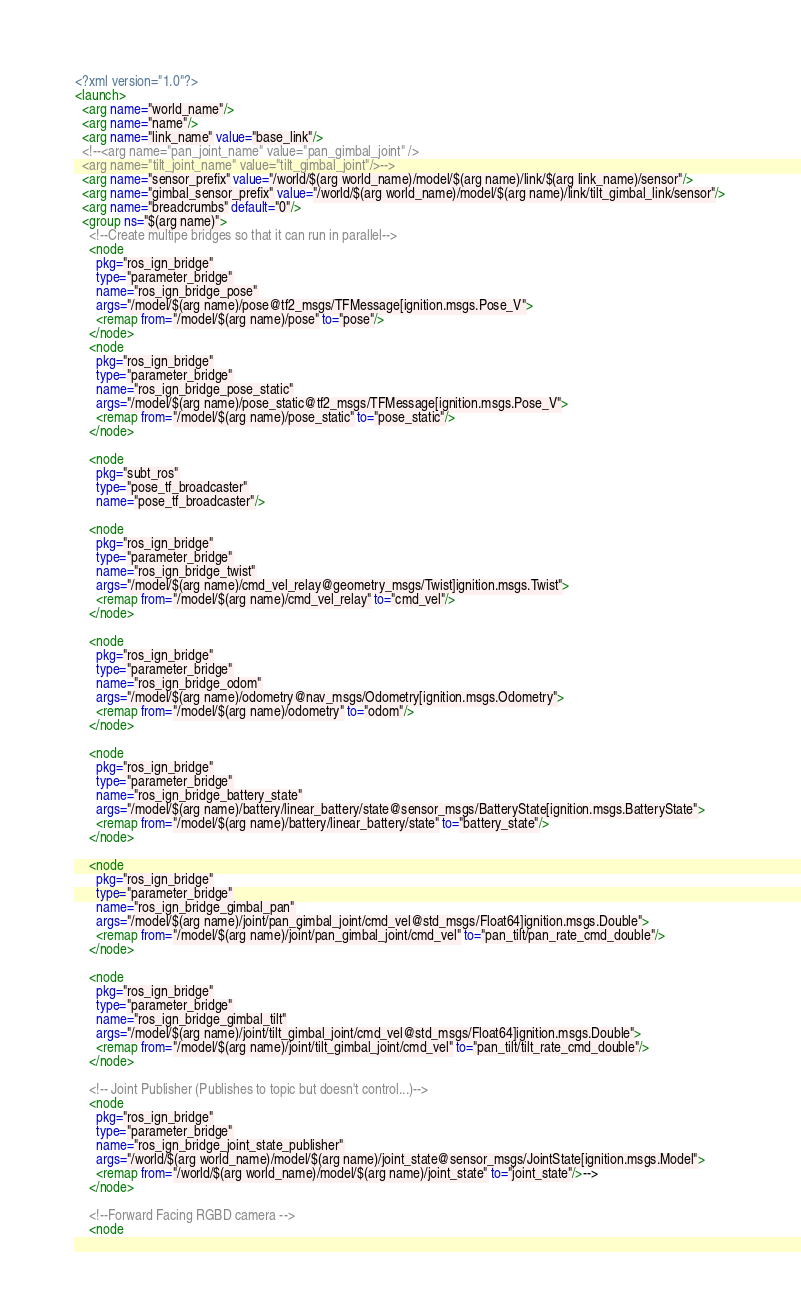<code> <loc_0><loc_0><loc_500><loc_500><_XML_><?xml version="1.0"?>
<launch>
  <arg name="world_name"/>
  <arg name="name"/>
  <arg name="link_name" value="base_link"/>
  <!--<arg name="pan_joint_name" value="pan_gimbal_joint" />
  <arg name="tilt_joint_name" value="tilt_gimbal_joint"/>-->
  <arg name="sensor_prefix" value="/world/$(arg world_name)/model/$(arg name)/link/$(arg link_name)/sensor"/>
  <arg name="gimbal_sensor_prefix" value="/world/$(arg world_name)/model/$(arg name)/link/tilt_gimbal_link/sensor"/>
  <arg name="breadcrumbs" default="0"/>
  <group ns="$(arg name)">
    <!--Create multipe bridges so that it can run in parallel-->
    <node
      pkg="ros_ign_bridge"
      type="parameter_bridge"
      name="ros_ign_bridge_pose"
      args="/model/$(arg name)/pose@tf2_msgs/TFMessage[ignition.msgs.Pose_V">
      <remap from="/model/$(arg name)/pose" to="pose"/>
    </node>
    <node
      pkg="ros_ign_bridge"
      type="parameter_bridge"
      name="ros_ign_bridge_pose_static"
      args="/model/$(arg name)/pose_static@tf2_msgs/TFMessage[ignition.msgs.Pose_V">
      <remap from="/model/$(arg name)/pose_static" to="pose_static"/>
    </node>

    <node
      pkg="subt_ros"
      type="pose_tf_broadcaster"
      name="pose_tf_broadcaster"/>

    <node
      pkg="ros_ign_bridge"
      type="parameter_bridge"
      name="ros_ign_bridge_twist"
      args="/model/$(arg name)/cmd_vel_relay@geometry_msgs/Twist]ignition.msgs.Twist">
      <remap from="/model/$(arg name)/cmd_vel_relay" to="cmd_vel"/>
    </node>

    <node
      pkg="ros_ign_bridge"
      type="parameter_bridge"
      name="ros_ign_bridge_odom"
      args="/model/$(arg name)/odometry@nav_msgs/Odometry[ignition.msgs.Odometry">
      <remap from="/model/$(arg name)/odometry" to="odom"/>
    </node>

    <node
      pkg="ros_ign_bridge"
      type="parameter_bridge"
      name="ros_ign_bridge_battery_state"
      args="/model/$(arg name)/battery/linear_battery/state@sensor_msgs/BatteryState[ignition.msgs.BatteryState">
      <remap from="/model/$(arg name)/battery/linear_battery/state" to="battery_state"/>
    </node>

    <node
      pkg="ros_ign_bridge"
      type="parameter_bridge"
      name="ros_ign_bridge_gimbal_pan"
      args="/model/$(arg name)/joint/pan_gimbal_joint/cmd_vel@std_msgs/Float64]ignition.msgs.Double">
      <remap from="/model/$(arg name)/joint/pan_gimbal_joint/cmd_vel" to="pan_tilt/pan_rate_cmd_double"/>
    </node>

    <node
      pkg="ros_ign_bridge"
      type="parameter_bridge"
      name="ros_ign_bridge_gimbal_tilt"
      args="/model/$(arg name)/joint/tilt_gimbal_joint/cmd_vel@std_msgs/Float64]ignition.msgs.Double">
      <remap from="/model/$(arg name)/joint/tilt_gimbal_joint/cmd_vel" to="pan_tilt/tilt_rate_cmd_double"/>
    </node>

    <!-- Joint Publisher (Publishes to topic but doesn't control...)-->
    <node
      pkg="ros_ign_bridge"
      type="parameter_bridge"
      name="ros_ign_bridge_joint_state_publisher"
      args="/world/$(arg world_name)/model/$(arg name)/joint_state@sensor_msgs/JointState[ignition.msgs.Model">
      <remap from="/world/$(arg world_name)/model/$(arg name)/joint_state" to="joint_state"/>-->
    </node>

    <!--Forward Facing RGBD camera -->
    <node</code> 